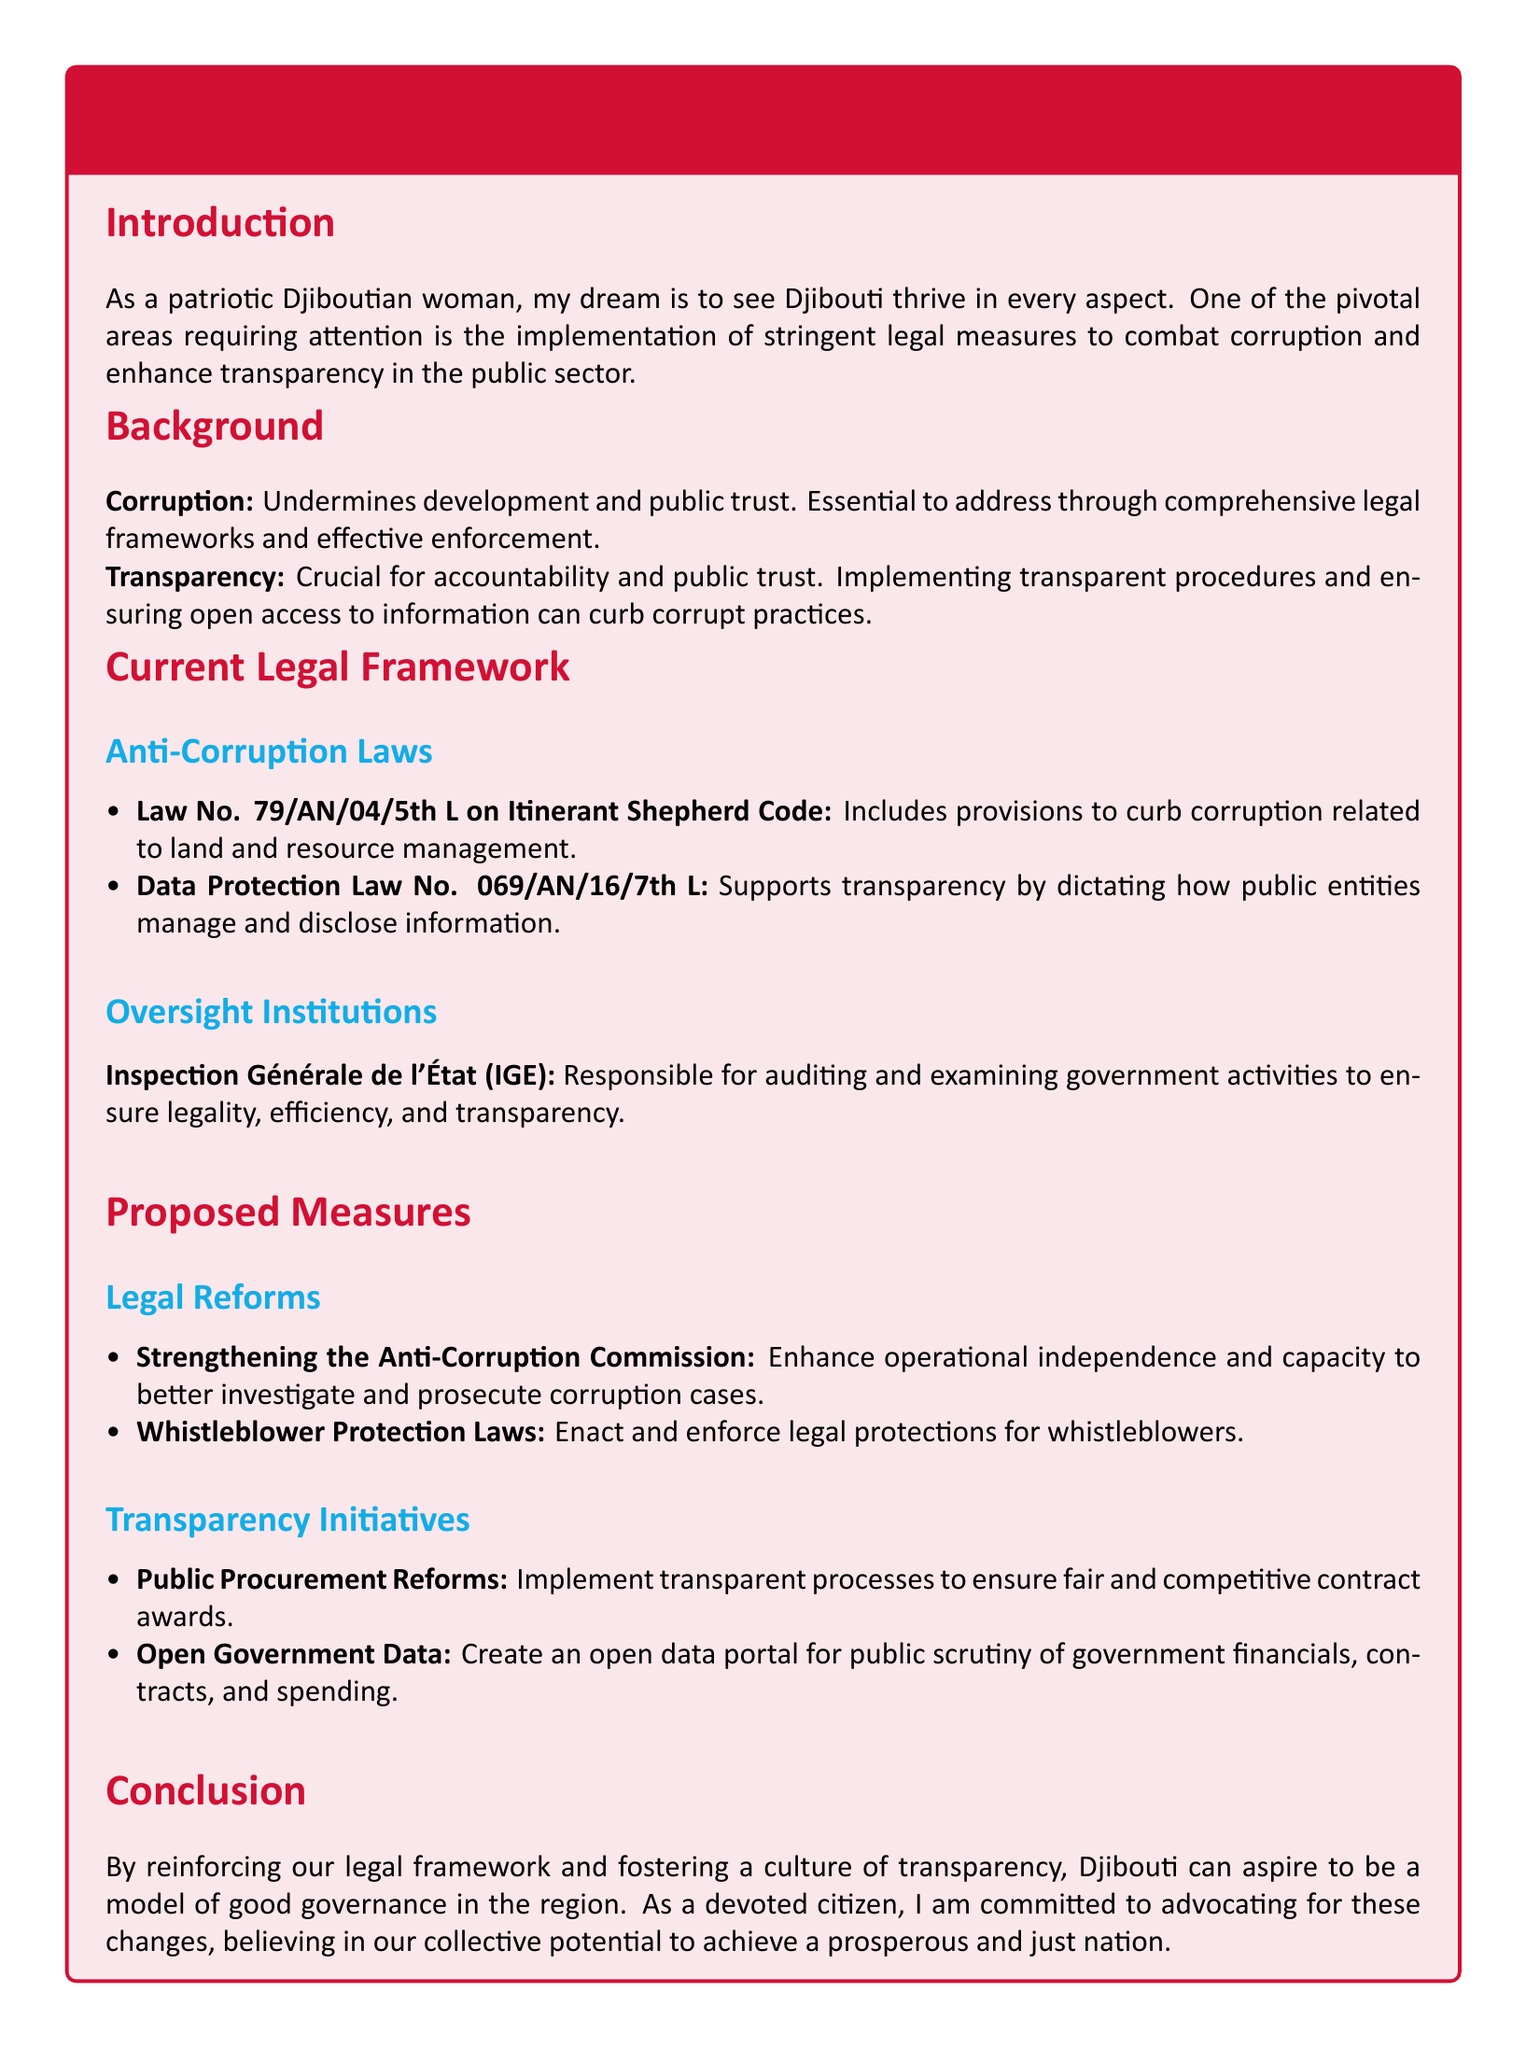What is the main theme of the document? The document discusses legal measures to combat corruption and promote transparency in Djibouti's public sector.
Answer: Legal measures to combat corruption and promote transparency What law is related to land and resource management? The document cites Law No. 79/AN/04/5th L which includes provisions related to corruption in land and resource management.
Answer: Law No. 79/AN/04/5th L What institution is responsible for auditing government activities? The Inspection Générale de l'État (IGE) is mentioned as responsible for auditing and examining government activities.
Answer: Inspection Générale de l'État (IGE) What proposed measure aims to protect whistleblowers? The document suggests enacting and enforcing whistleblower protection laws.
Answer: Whistleblower Protection Laws How many laws are listed under the current legal framework? There are two laws mentioned in the document under the current legal framework.
Answer: Two laws What is a proposed initiative to improve public procurement? Public procurement reforms are proposed to implement transparent processes for contract awards.
Answer: Public procurement reforms What is one of the goals of the proposed legal reforms? The goal is to strengthen the Anti-Corruption Commission's independence and capacity.
Answer: Strengthening the Anti-Corruption Commission What does the conclusion emphasize for Djibouti? The conclusion emphasizes the aspiration for Djibouti to be a model of good governance.
Answer: A model of good governance 